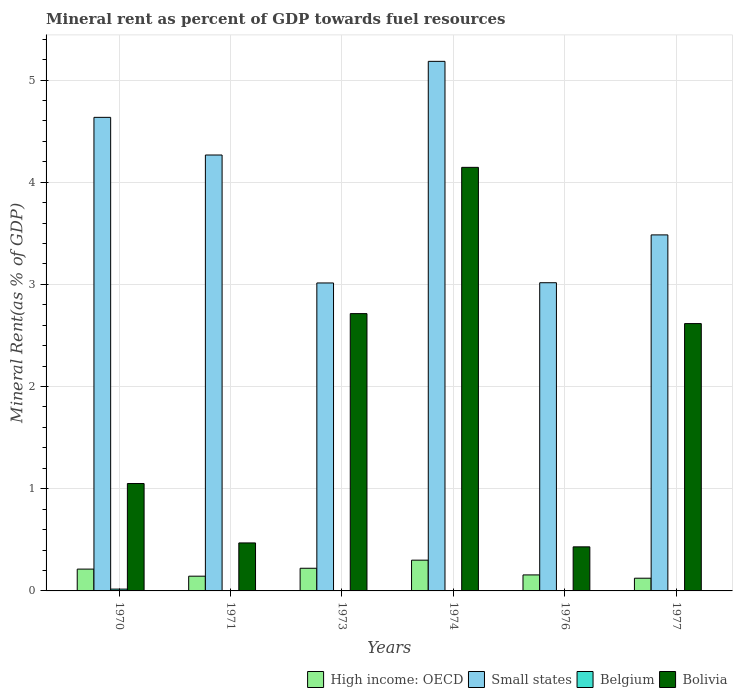How many different coloured bars are there?
Keep it short and to the point. 4. Are the number of bars per tick equal to the number of legend labels?
Provide a short and direct response. Yes. Are the number of bars on each tick of the X-axis equal?
Give a very brief answer. Yes. How many bars are there on the 5th tick from the left?
Ensure brevity in your answer.  4. What is the label of the 6th group of bars from the left?
Your answer should be very brief. 1977. In how many cases, is the number of bars for a given year not equal to the number of legend labels?
Give a very brief answer. 0. What is the mineral rent in Bolivia in 1976?
Your answer should be compact. 0.43. Across all years, what is the maximum mineral rent in Belgium?
Provide a short and direct response. 0.02. Across all years, what is the minimum mineral rent in Small states?
Provide a succinct answer. 3.01. In which year was the mineral rent in High income: OECD maximum?
Provide a short and direct response. 1974. In which year was the mineral rent in High income: OECD minimum?
Provide a succinct answer. 1977. What is the total mineral rent in Small states in the graph?
Your response must be concise. 23.6. What is the difference between the mineral rent in Bolivia in 1973 and that in 1977?
Your answer should be very brief. 0.1. What is the difference between the mineral rent in Belgium in 1973 and the mineral rent in Small states in 1976?
Provide a succinct answer. -3.02. What is the average mineral rent in Small states per year?
Ensure brevity in your answer.  3.93. In the year 1970, what is the difference between the mineral rent in Belgium and mineral rent in High income: OECD?
Ensure brevity in your answer.  -0.2. What is the ratio of the mineral rent in Bolivia in 1971 to that in 1977?
Ensure brevity in your answer.  0.18. Is the mineral rent in Belgium in 1973 less than that in 1977?
Give a very brief answer. Yes. Is the difference between the mineral rent in Belgium in 1971 and 1977 greater than the difference between the mineral rent in High income: OECD in 1971 and 1977?
Provide a succinct answer. No. What is the difference between the highest and the second highest mineral rent in Bolivia?
Give a very brief answer. 1.43. What is the difference between the highest and the lowest mineral rent in Bolivia?
Make the answer very short. 3.71. Is the sum of the mineral rent in Bolivia in 1973 and 1976 greater than the maximum mineral rent in High income: OECD across all years?
Keep it short and to the point. Yes. What does the 3rd bar from the right in 1970 represents?
Your response must be concise. Small states. Are all the bars in the graph horizontal?
Provide a short and direct response. No. How many years are there in the graph?
Keep it short and to the point. 6. Does the graph contain grids?
Offer a very short reply. Yes. What is the title of the graph?
Offer a terse response. Mineral rent as percent of GDP towards fuel resources. Does "Antigua and Barbuda" appear as one of the legend labels in the graph?
Provide a short and direct response. No. What is the label or title of the Y-axis?
Ensure brevity in your answer.  Mineral Rent(as % of GDP). What is the Mineral Rent(as % of GDP) of High income: OECD in 1970?
Provide a succinct answer. 0.21. What is the Mineral Rent(as % of GDP) in Small states in 1970?
Provide a short and direct response. 4.63. What is the Mineral Rent(as % of GDP) of Belgium in 1970?
Offer a terse response. 0.02. What is the Mineral Rent(as % of GDP) in Bolivia in 1970?
Offer a terse response. 1.05. What is the Mineral Rent(as % of GDP) in High income: OECD in 1971?
Your response must be concise. 0.14. What is the Mineral Rent(as % of GDP) of Small states in 1971?
Your answer should be compact. 4.27. What is the Mineral Rent(as % of GDP) in Belgium in 1971?
Make the answer very short. 0. What is the Mineral Rent(as % of GDP) of Bolivia in 1971?
Make the answer very short. 0.47. What is the Mineral Rent(as % of GDP) of High income: OECD in 1973?
Provide a short and direct response. 0.22. What is the Mineral Rent(as % of GDP) in Small states in 1973?
Ensure brevity in your answer.  3.01. What is the Mineral Rent(as % of GDP) in Belgium in 1973?
Provide a succinct answer. 0. What is the Mineral Rent(as % of GDP) of Bolivia in 1973?
Keep it short and to the point. 2.71. What is the Mineral Rent(as % of GDP) in High income: OECD in 1974?
Your answer should be very brief. 0.3. What is the Mineral Rent(as % of GDP) in Small states in 1974?
Give a very brief answer. 5.18. What is the Mineral Rent(as % of GDP) of Belgium in 1974?
Ensure brevity in your answer.  0. What is the Mineral Rent(as % of GDP) of Bolivia in 1974?
Offer a terse response. 4.15. What is the Mineral Rent(as % of GDP) of High income: OECD in 1976?
Offer a terse response. 0.16. What is the Mineral Rent(as % of GDP) of Small states in 1976?
Make the answer very short. 3.02. What is the Mineral Rent(as % of GDP) in Belgium in 1976?
Your answer should be compact. 0. What is the Mineral Rent(as % of GDP) of Bolivia in 1976?
Make the answer very short. 0.43. What is the Mineral Rent(as % of GDP) in High income: OECD in 1977?
Your answer should be very brief. 0.12. What is the Mineral Rent(as % of GDP) of Small states in 1977?
Keep it short and to the point. 3.48. What is the Mineral Rent(as % of GDP) in Belgium in 1977?
Provide a short and direct response. 0. What is the Mineral Rent(as % of GDP) of Bolivia in 1977?
Keep it short and to the point. 2.62. Across all years, what is the maximum Mineral Rent(as % of GDP) in High income: OECD?
Ensure brevity in your answer.  0.3. Across all years, what is the maximum Mineral Rent(as % of GDP) of Small states?
Give a very brief answer. 5.18. Across all years, what is the maximum Mineral Rent(as % of GDP) in Belgium?
Provide a short and direct response. 0.02. Across all years, what is the maximum Mineral Rent(as % of GDP) in Bolivia?
Keep it short and to the point. 4.15. Across all years, what is the minimum Mineral Rent(as % of GDP) of High income: OECD?
Your response must be concise. 0.12. Across all years, what is the minimum Mineral Rent(as % of GDP) of Small states?
Ensure brevity in your answer.  3.01. Across all years, what is the minimum Mineral Rent(as % of GDP) in Belgium?
Offer a terse response. 0. Across all years, what is the minimum Mineral Rent(as % of GDP) of Bolivia?
Provide a short and direct response. 0.43. What is the total Mineral Rent(as % of GDP) of High income: OECD in the graph?
Your answer should be compact. 1.16. What is the total Mineral Rent(as % of GDP) of Small states in the graph?
Provide a succinct answer. 23.6. What is the total Mineral Rent(as % of GDP) in Belgium in the graph?
Offer a terse response. 0.03. What is the total Mineral Rent(as % of GDP) in Bolivia in the graph?
Your response must be concise. 11.43. What is the difference between the Mineral Rent(as % of GDP) in High income: OECD in 1970 and that in 1971?
Keep it short and to the point. 0.07. What is the difference between the Mineral Rent(as % of GDP) in Small states in 1970 and that in 1971?
Offer a terse response. 0.37. What is the difference between the Mineral Rent(as % of GDP) in Belgium in 1970 and that in 1971?
Provide a succinct answer. 0.02. What is the difference between the Mineral Rent(as % of GDP) in Bolivia in 1970 and that in 1971?
Your answer should be very brief. 0.58. What is the difference between the Mineral Rent(as % of GDP) in High income: OECD in 1970 and that in 1973?
Provide a short and direct response. -0.01. What is the difference between the Mineral Rent(as % of GDP) in Small states in 1970 and that in 1973?
Your answer should be very brief. 1.62. What is the difference between the Mineral Rent(as % of GDP) in Belgium in 1970 and that in 1973?
Your answer should be compact. 0.02. What is the difference between the Mineral Rent(as % of GDP) in Bolivia in 1970 and that in 1973?
Offer a very short reply. -1.66. What is the difference between the Mineral Rent(as % of GDP) of High income: OECD in 1970 and that in 1974?
Ensure brevity in your answer.  -0.09. What is the difference between the Mineral Rent(as % of GDP) in Small states in 1970 and that in 1974?
Your answer should be very brief. -0.55. What is the difference between the Mineral Rent(as % of GDP) of Belgium in 1970 and that in 1974?
Your answer should be compact. 0.01. What is the difference between the Mineral Rent(as % of GDP) in Bolivia in 1970 and that in 1974?
Offer a very short reply. -3.09. What is the difference between the Mineral Rent(as % of GDP) in High income: OECD in 1970 and that in 1976?
Give a very brief answer. 0.06. What is the difference between the Mineral Rent(as % of GDP) in Small states in 1970 and that in 1976?
Your answer should be compact. 1.62. What is the difference between the Mineral Rent(as % of GDP) in Belgium in 1970 and that in 1976?
Your response must be concise. 0.01. What is the difference between the Mineral Rent(as % of GDP) in Bolivia in 1970 and that in 1976?
Your response must be concise. 0.62. What is the difference between the Mineral Rent(as % of GDP) of High income: OECD in 1970 and that in 1977?
Ensure brevity in your answer.  0.09. What is the difference between the Mineral Rent(as % of GDP) in Small states in 1970 and that in 1977?
Offer a very short reply. 1.15. What is the difference between the Mineral Rent(as % of GDP) of Belgium in 1970 and that in 1977?
Give a very brief answer. 0.02. What is the difference between the Mineral Rent(as % of GDP) of Bolivia in 1970 and that in 1977?
Offer a terse response. -1.57. What is the difference between the Mineral Rent(as % of GDP) of High income: OECD in 1971 and that in 1973?
Your answer should be very brief. -0.08. What is the difference between the Mineral Rent(as % of GDP) in Small states in 1971 and that in 1973?
Make the answer very short. 1.25. What is the difference between the Mineral Rent(as % of GDP) in Belgium in 1971 and that in 1973?
Your answer should be compact. 0. What is the difference between the Mineral Rent(as % of GDP) in Bolivia in 1971 and that in 1973?
Provide a short and direct response. -2.24. What is the difference between the Mineral Rent(as % of GDP) in High income: OECD in 1971 and that in 1974?
Make the answer very short. -0.16. What is the difference between the Mineral Rent(as % of GDP) of Small states in 1971 and that in 1974?
Give a very brief answer. -0.92. What is the difference between the Mineral Rent(as % of GDP) of Belgium in 1971 and that in 1974?
Give a very brief answer. -0. What is the difference between the Mineral Rent(as % of GDP) in Bolivia in 1971 and that in 1974?
Provide a succinct answer. -3.68. What is the difference between the Mineral Rent(as % of GDP) in High income: OECD in 1971 and that in 1976?
Your answer should be compact. -0.01. What is the difference between the Mineral Rent(as % of GDP) of Small states in 1971 and that in 1976?
Your response must be concise. 1.25. What is the difference between the Mineral Rent(as % of GDP) of Belgium in 1971 and that in 1976?
Give a very brief answer. -0. What is the difference between the Mineral Rent(as % of GDP) of Bolivia in 1971 and that in 1976?
Your answer should be compact. 0.04. What is the difference between the Mineral Rent(as % of GDP) of High income: OECD in 1971 and that in 1977?
Make the answer very short. 0.02. What is the difference between the Mineral Rent(as % of GDP) in Small states in 1971 and that in 1977?
Offer a terse response. 0.78. What is the difference between the Mineral Rent(as % of GDP) in Belgium in 1971 and that in 1977?
Provide a short and direct response. -0. What is the difference between the Mineral Rent(as % of GDP) in Bolivia in 1971 and that in 1977?
Ensure brevity in your answer.  -2.15. What is the difference between the Mineral Rent(as % of GDP) of High income: OECD in 1973 and that in 1974?
Ensure brevity in your answer.  -0.08. What is the difference between the Mineral Rent(as % of GDP) of Small states in 1973 and that in 1974?
Your response must be concise. -2.17. What is the difference between the Mineral Rent(as % of GDP) of Belgium in 1973 and that in 1974?
Ensure brevity in your answer.  -0. What is the difference between the Mineral Rent(as % of GDP) in Bolivia in 1973 and that in 1974?
Give a very brief answer. -1.43. What is the difference between the Mineral Rent(as % of GDP) in High income: OECD in 1973 and that in 1976?
Your response must be concise. 0.07. What is the difference between the Mineral Rent(as % of GDP) in Small states in 1973 and that in 1976?
Your response must be concise. -0. What is the difference between the Mineral Rent(as % of GDP) of Belgium in 1973 and that in 1976?
Keep it short and to the point. -0. What is the difference between the Mineral Rent(as % of GDP) of Bolivia in 1973 and that in 1976?
Your answer should be compact. 2.28. What is the difference between the Mineral Rent(as % of GDP) of High income: OECD in 1973 and that in 1977?
Your answer should be compact. 0.1. What is the difference between the Mineral Rent(as % of GDP) of Small states in 1973 and that in 1977?
Your response must be concise. -0.47. What is the difference between the Mineral Rent(as % of GDP) of Belgium in 1973 and that in 1977?
Ensure brevity in your answer.  -0. What is the difference between the Mineral Rent(as % of GDP) in Bolivia in 1973 and that in 1977?
Your answer should be compact. 0.1. What is the difference between the Mineral Rent(as % of GDP) of High income: OECD in 1974 and that in 1976?
Give a very brief answer. 0.14. What is the difference between the Mineral Rent(as % of GDP) in Small states in 1974 and that in 1976?
Give a very brief answer. 2.17. What is the difference between the Mineral Rent(as % of GDP) of Belgium in 1974 and that in 1976?
Provide a succinct answer. -0. What is the difference between the Mineral Rent(as % of GDP) in Bolivia in 1974 and that in 1976?
Ensure brevity in your answer.  3.71. What is the difference between the Mineral Rent(as % of GDP) in High income: OECD in 1974 and that in 1977?
Offer a terse response. 0.18. What is the difference between the Mineral Rent(as % of GDP) in Small states in 1974 and that in 1977?
Offer a very short reply. 1.7. What is the difference between the Mineral Rent(as % of GDP) of Belgium in 1974 and that in 1977?
Your response must be concise. 0. What is the difference between the Mineral Rent(as % of GDP) in Bolivia in 1974 and that in 1977?
Keep it short and to the point. 1.53. What is the difference between the Mineral Rent(as % of GDP) in High income: OECD in 1976 and that in 1977?
Offer a terse response. 0.03. What is the difference between the Mineral Rent(as % of GDP) in Small states in 1976 and that in 1977?
Ensure brevity in your answer.  -0.47. What is the difference between the Mineral Rent(as % of GDP) of Belgium in 1976 and that in 1977?
Make the answer very short. 0. What is the difference between the Mineral Rent(as % of GDP) of Bolivia in 1976 and that in 1977?
Make the answer very short. -2.19. What is the difference between the Mineral Rent(as % of GDP) in High income: OECD in 1970 and the Mineral Rent(as % of GDP) in Small states in 1971?
Your answer should be compact. -4.05. What is the difference between the Mineral Rent(as % of GDP) in High income: OECD in 1970 and the Mineral Rent(as % of GDP) in Belgium in 1971?
Your answer should be very brief. 0.21. What is the difference between the Mineral Rent(as % of GDP) of High income: OECD in 1970 and the Mineral Rent(as % of GDP) of Bolivia in 1971?
Make the answer very short. -0.26. What is the difference between the Mineral Rent(as % of GDP) of Small states in 1970 and the Mineral Rent(as % of GDP) of Belgium in 1971?
Provide a succinct answer. 4.63. What is the difference between the Mineral Rent(as % of GDP) of Small states in 1970 and the Mineral Rent(as % of GDP) of Bolivia in 1971?
Your answer should be compact. 4.16. What is the difference between the Mineral Rent(as % of GDP) in Belgium in 1970 and the Mineral Rent(as % of GDP) in Bolivia in 1971?
Your answer should be compact. -0.45. What is the difference between the Mineral Rent(as % of GDP) of High income: OECD in 1970 and the Mineral Rent(as % of GDP) of Small states in 1973?
Offer a terse response. -2.8. What is the difference between the Mineral Rent(as % of GDP) of High income: OECD in 1970 and the Mineral Rent(as % of GDP) of Belgium in 1973?
Your answer should be very brief. 0.21. What is the difference between the Mineral Rent(as % of GDP) of High income: OECD in 1970 and the Mineral Rent(as % of GDP) of Bolivia in 1973?
Your answer should be compact. -2.5. What is the difference between the Mineral Rent(as % of GDP) in Small states in 1970 and the Mineral Rent(as % of GDP) in Belgium in 1973?
Ensure brevity in your answer.  4.63. What is the difference between the Mineral Rent(as % of GDP) in Small states in 1970 and the Mineral Rent(as % of GDP) in Bolivia in 1973?
Offer a terse response. 1.92. What is the difference between the Mineral Rent(as % of GDP) in Belgium in 1970 and the Mineral Rent(as % of GDP) in Bolivia in 1973?
Give a very brief answer. -2.7. What is the difference between the Mineral Rent(as % of GDP) of High income: OECD in 1970 and the Mineral Rent(as % of GDP) of Small states in 1974?
Keep it short and to the point. -4.97. What is the difference between the Mineral Rent(as % of GDP) in High income: OECD in 1970 and the Mineral Rent(as % of GDP) in Belgium in 1974?
Ensure brevity in your answer.  0.21. What is the difference between the Mineral Rent(as % of GDP) in High income: OECD in 1970 and the Mineral Rent(as % of GDP) in Bolivia in 1974?
Give a very brief answer. -3.93. What is the difference between the Mineral Rent(as % of GDP) of Small states in 1970 and the Mineral Rent(as % of GDP) of Belgium in 1974?
Ensure brevity in your answer.  4.63. What is the difference between the Mineral Rent(as % of GDP) of Small states in 1970 and the Mineral Rent(as % of GDP) of Bolivia in 1974?
Your response must be concise. 0.49. What is the difference between the Mineral Rent(as % of GDP) in Belgium in 1970 and the Mineral Rent(as % of GDP) in Bolivia in 1974?
Offer a terse response. -4.13. What is the difference between the Mineral Rent(as % of GDP) in High income: OECD in 1970 and the Mineral Rent(as % of GDP) in Small states in 1976?
Keep it short and to the point. -2.8. What is the difference between the Mineral Rent(as % of GDP) in High income: OECD in 1970 and the Mineral Rent(as % of GDP) in Belgium in 1976?
Ensure brevity in your answer.  0.21. What is the difference between the Mineral Rent(as % of GDP) in High income: OECD in 1970 and the Mineral Rent(as % of GDP) in Bolivia in 1976?
Your answer should be compact. -0.22. What is the difference between the Mineral Rent(as % of GDP) in Small states in 1970 and the Mineral Rent(as % of GDP) in Belgium in 1976?
Your answer should be very brief. 4.63. What is the difference between the Mineral Rent(as % of GDP) of Small states in 1970 and the Mineral Rent(as % of GDP) of Bolivia in 1976?
Make the answer very short. 4.2. What is the difference between the Mineral Rent(as % of GDP) of Belgium in 1970 and the Mineral Rent(as % of GDP) of Bolivia in 1976?
Your response must be concise. -0.41. What is the difference between the Mineral Rent(as % of GDP) of High income: OECD in 1970 and the Mineral Rent(as % of GDP) of Small states in 1977?
Provide a short and direct response. -3.27. What is the difference between the Mineral Rent(as % of GDP) in High income: OECD in 1970 and the Mineral Rent(as % of GDP) in Belgium in 1977?
Your response must be concise. 0.21. What is the difference between the Mineral Rent(as % of GDP) of High income: OECD in 1970 and the Mineral Rent(as % of GDP) of Bolivia in 1977?
Your answer should be very brief. -2.4. What is the difference between the Mineral Rent(as % of GDP) in Small states in 1970 and the Mineral Rent(as % of GDP) in Belgium in 1977?
Make the answer very short. 4.63. What is the difference between the Mineral Rent(as % of GDP) in Small states in 1970 and the Mineral Rent(as % of GDP) in Bolivia in 1977?
Provide a short and direct response. 2.02. What is the difference between the Mineral Rent(as % of GDP) in Belgium in 1970 and the Mineral Rent(as % of GDP) in Bolivia in 1977?
Give a very brief answer. -2.6. What is the difference between the Mineral Rent(as % of GDP) in High income: OECD in 1971 and the Mineral Rent(as % of GDP) in Small states in 1973?
Ensure brevity in your answer.  -2.87. What is the difference between the Mineral Rent(as % of GDP) of High income: OECD in 1971 and the Mineral Rent(as % of GDP) of Belgium in 1973?
Provide a short and direct response. 0.14. What is the difference between the Mineral Rent(as % of GDP) in High income: OECD in 1971 and the Mineral Rent(as % of GDP) in Bolivia in 1973?
Your response must be concise. -2.57. What is the difference between the Mineral Rent(as % of GDP) in Small states in 1971 and the Mineral Rent(as % of GDP) in Belgium in 1973?
Ensure brevity in your answer.  4.27. What is the difference between the Mineral Rent(as % of GDP) of Small states in 1971 and the Mineral Rent(as % of GDP) of Bolivia in 1973?
Give a very brief answer. 1.55. What is the difference between the Mineral Rent(as % of GDP) in Belgium in 1971 and the Mineral Rent(as % of GDP) in Bolivia in 1973?
Keep it short and to the point. -2.71. What is the difference between the Mineral Rent(as % of GDP) of High income: OECD in 1971 and the Mineral Rent(as % of GDP) of Small states in 1974?
Offer a terse response. -5.04. What is the difference between the Mineral Rent(as % of GDP) in High income: OECD in 1971 and the Mineral Rent(as % of GDP) in Belgium in 1974?
Provide a succinct answer. 0.14. What is the difference between the Mineral Rent(as % of GDP) of High income: OECD in 1971 and the Mineral Rent(as % of GDP) of Bolivia in 1974?
Your response must be concise. -4. What is the difference between the Mineral Rent(as % of GDP) of Small states in 1971 and the Mineral Rent(as % of GDP) of Belgium in 1974?
Ensure brevity in your answer.  4.26. What is the difference between the Mineral Rent(as % of GDP) in Small states in 1971 and the Mineral Rent(as % of GDP) in Bolivia in 1974?
Offer a terse response. 0.12. What is the difference between the Mineral Rent(as % of GDP) of Belgium in 1971 and the Mineral Rent(as % of GDP) of Bolivia in 1974?
Give a very brief answer. -4.14. What is the difference between the Mineral Rent(as % of GDP) in High income: OECD in 1971 and the Mineral Rent(as % of GDP) in Small states in 1976?
Your response must be concise. -2.87. What is the difference between the Mineral Rent(as % of GDP) of High income: OECD in 1971 and the Mineral Rent(as % of GDP) of Belgium in 1976?
Provide a succinct answer. 0.14. What is the difference between the Mineral Rent(as % of GDP) of High income: OECD in 1971 and the Mineral Rent(as % of GDP) of Bolivia in 1976?
Provide a short and direct response. -0.29. What is the difference between the Mineral Rent(as % of GDP) of Small states in 1971 and the Mineral Rent(as % of GDP) of Belgium in 1976?
Provide a succinct answer. 4.26. What is the difference between the Mineral Rent(as % of GDP) in Small states in 1971 and the Mineral Rent(as % of GDP) in Bolivia in 1976?
Ensure brevity in your answer.  3.83. What is the difference between the Mineral Rent(as % of GDP) of Belgium in 1971 and the Mineral Rent(as % of GDP) of Bolivia in 1976?
Provide a succinct answer. -0.43. What is the difference between the Mineral Rent(as % of GDP) in High income: OECD in 1971 and the Mineral Rent(as % of GDP) in Small states in 1977?
Your answer should be compact. -3.34. What is the difference between the Mineral Rent(as % of GDP) in High income: OECD in 1971 and the Mineral Rent(as % of GDP) in Belgium in 1977?
Your answer should be compact. 0.14. What is the difference between the Mineral Rent(as % of GDP) of High income: OECD in 1971 and the Mineral Rent(as % of GDP) of Bolivia in 1977?
Your response must be concise. -2.47. What is the difference between the Mineral Rent(as % of GDP) of Small states in 1971 and the Mineral Rent(as % of GDP) of Belgium in 1977?
Provide a short and direct response. 4.26. What is the difference between the Mineral Rent(as % of GDP) in Small states in 1971 and the Mineral Rent(as % of GDP) in Bolivia in 1977?
Your answer should be very brief. 1.65. What is the difference between the Mineral Rent(as % of GDP) in Belgium in 1971 and the Mineral Rent(as % of GDP) in Bolivia in 1977?
Provide a succinct answer. -2.62. What is the difference between the Mineral Rent(as % of GDP) of High income: OECD in 1973 and the Mineral Rent(as % of GDP) of Small states in 1974?
Provide a succinct answer. -4.96. What is the difference between the Mineral Rent(as % of GDP) in High income: OECD in 1973 and the Mineral Rent(as % of GDP) in Belgium in 1974?
Make the answer very short. 0.22. What is the difference between the Mineral Rent(as % of GDP) in High income: OECD in 1973 and the Mineral Rent(as % of GDP) in Bolivia in 1974?
Provide a succinct answer. -3.92. What is the difference between the Mineral Rent(as % of GDP) of Small states in 1973 and the Mineral Rent(as % of GDP) of Belgium in 1974?
Give a very brief answer. 3.01. What is the difference between the Mineral Rent(as % of GDP) of Small states in 1973 and the Mineral Rent(as % of GDP) of Bolivia in 1974?
Make the answer very short. -1.13. What is the difference between the Mineral Rent(as % of GDP) of Belgium in 1973 and the Mineral Rent(as % of GDP) of Bolivia in 1974?
Ensure brevity in your answer.  -4.14. What is the difference between the Mineral Rent(as % of GDP) in High income: OECD in 1973 and the Mineral Rent(as % of GDP) in Small states in 1976?
Keep it short and to the point. -2.79. What is the difference between the Mineral Rent(as % of GDP) in High income: OECD in 1973 and the Mineral Rent(as % of GDP) in Belgium in 1976?
Ensure brevity in your answer.  0.22. What is the difference between the Mineral Rent(as % of GDP) in High income: OECD in 1973 and the Mineral Rent(as % of GDP) in Bolivia in 1976?
Give a very brief answer. -0.21. What is the difference between the Mineral Rent(as % of GDP) in Small states in 1973 and the Mineral Rent(as % of GDP) in Belgium in 1976?
Ensure brevity in your answer.  3.01. What is the difference between the Mineral Rent(as % of GDP) of Small states in 1973 and the Mineral Rent(as % of GDP) of Bolivia in 1976?
Your answer should be compact. 2.58. What is the difference between the Mineral Rent(as % of GDP) of Belgium in 1973 and the Mineral Rent(as % of GDP) of Bolivia in 1976?
Offer a terse response. -0.43. What is the difference between the Mineral Rent(as % of GDP) in High income: OECD in 1973 and the Mineral Rent(as % of GDP) in Small states in 1977?
Offer a very short reply. -3.26. What is the difference between the Mineral Rent(as % of GDP) in High income: OECD in 1973 and the Mineral Rent(as % of GDP) in Belgium in 1977?
Make the answer very short. 0.22. What is the difference between the Mineral Rent(as % of GDP) in High income: OECD in 1973 and the Mineral Rent(as % of GDP) in Bolivia in 1977?
Offer a very short reply. -2.39. What is the difference between the Mineral Rent(as % of GDP) in Small states in 1973 and the Mineral Rent(as % of GDP) in Belgium in 1977?
Offer a very short reply. 3.01. What is the difference between the Mineral Rent(as % of GDP) in Small states in 1973 and the Mineral Rent(as % of GDP) in Bolivia in 1977?
Your response must be concise. 0.4. What is the difference between the Mineral Rent(as % of GDP) in Belgium in 1973 and the Mineral Rent(as % of GDP) in Bolivia in 1977?
Your answer should be compact. -2.62. What is the difference between the Mineral Rent(as % of GDP) in High income: OECD in 1974 and the Mineral Rent(as % of GDP) in Small states in 1976?
Keep it short and to the point. -2.72. What is the difference between the Mineral Rent(as % of GDP) of High income: OECD in 1974 and the Mineral Rent(as % of GDP) of Belgium in 1976?
Keep it short and to the point. 0.3. What is the difference between the Mineral Rent(as % of GDP) in High income: OECD in 1974 and the Mineral Rent(as % of GDP) in Bolivia in 1976?
Provide a succinct answer. -0.13. What is the difference between the Mineral Rent(as % of GDP) in Small states in 1974 and the Mineral Rent(as % of GDP) in Belgium in 1976?
Keep it short and to the point. 5.18. What is the difference between the Mineral Rent(as % of GDP) in Small states in 1974 and the Mineral Rent(as % of GDP) in Bolivia in 1976?
Make the answer very short. 4.75. What is the difference between the Mineral Rent(as % of GDP) of Belgium in 1974 and the Mineral Rent(as % of GDP) of Bolivia in 1976?
Provide a succinct answer. -0.43. What is the difference between the Mineral Rent(as % of GDP) of High income: OECD in 1974 and the Mineral Rent(as % of GDP) of Small states in 1977?
Provide a short and direct response. -3.18. What is the difference between the Mineral Rent(as % of GDP) in High income: OECD in 1974 and the Mineral Rent(as % of GDP) in Belgium in 1977?
Give a very brief answer. 0.3. What is the difference between the Mineral Rent(as % of GDP) in High income: OECD in 1974 and the Mineral Rent(as % of GDP) in Bolivia in 1977?
Provide a succinct answer. -2.32. What is the difference between the Mineral Rent(as % of GDP) of Small states in 1974 and the Mineral Rent(as % of GDP) of Belgium in 1977?
Ensure brevity in your answer.  5.18. What is the difference between the Mineral Rent(as % of GDP) of Small states in 1974 and the Mineral Rent(as % of GDP) of Bolivia in 1977?
Provide a short and direct response. 2.57. What is the difference between the Mineral Rent(as % of GDP) in Belgium in 1974 and the Mineral Rent(as % of GDP) in Bolivia in 1977?
Give a very brief answer. -2.61. What is the difference between the Mineral Rent(as % of GDP) of High income: OECD in 1976 and the Mineral Rent(as % of GDP) of Small states in 1977?
Your answer should be compact. -3.33. What is the difference between the Mineral Rent(as % of GDP) of High income: OECD in 1976 and the Mineral Rent(as % of GDP) of Belgium in 1977?
Your response must be concise. 0.16. What is the difference between the Mineral Rent(as % of GDP) in High income: OECD in 1976 and the Mineral Rent(as % of GDP) in Bolivia in 1977?
Provide a short and direct response. -2.46. What is the difference between the Mineral Rent(as % of GDP) in Small states in 1976 and the Mineral Rent(as % of GDP) in Belgium in 1977?
Provide a succinct answer. 3.01. What is the difference between the Mineral Rent(as % of GDP) of Small states in 1976 and the Mineral Rent(as % of GDP) of Bolivia in 1977?
Keep it short and to the point. 0.4. What is the difference between the Mineral Rent(as % of GDP) in Belgium in 1976 and the Mineral Rent(as % of GDP) in Bolivia in 1977?
Offer a very short reply. -2.61. What is the average Mineral Rent(as % of GDP) in High income: OECD per year?
Your response must be concise. 0.19. What is the average Mineral Rent(as % of GDP) in Small states per year?
Offer a very short reply. 3.93. What is the average Mineral Rent(as % of GDP) in Belgium per year?
Provide a short and direct response. 0. What is the average Mineral Rent(as % of GDP) in Bolivia per year?
Your response must be concise. 1.9. In the year 1970, what is the difference between the Mineral Rent(as % of GDP) of High income: OECD and Mineral Rent(as % of GDP) of Small states?
Provide a short and direct response. -4.42. In the year 1970, what is the difference between the Mineral Rent(as % of GDP) of High income: OECD and Mineral Rent(as % of GDP) of Belgium?
Offer a terse response. 0.2. In the year 1970, what is the difference between the Mineral Rent(as % of GDP) in High income: OECD and Mineral Rent(as % of GDP) in Bolivia?
Your answer should be compact. -0.84. In the year 1970, what is the difference between the Mineral Rent(as % of GDP) of Small states and Mineral Rent(as % of GDP) of Belgium?
Provide a short and direct response. 4.62. In the year 1970, what is the difference between the Mineral Rent(as % of GDP) of Small states and Mineral Rent(as % of GDP) of Bolivia?
Offer a very short reply. 3.58. In the year 1970, what is the difference between the Mineral Rent(as % of GDP) of Belgium and Mineral Rent(as % of GDP) of Bolivia?
Your answer should be compact. -1.03. In the year 1971, what is the difference between the Mineral Rent(as % of GDP) of High income: OECD and Mineral Rent(as % of GDP) of Small states?
Give a very brief answer. -4.12. In the year 1971, what is the difference between the Mineral Rent(as % of GDP) in High income: OECD and Mineral Rent(as % of GDP) in Belgium?
Ensure brevity in your answer.  0.14. In the year 1971, what is the difference between the Mineral Rent(as % of GDP) in High income: OECD and Mineral Rent(as % of GDP) in Bolivia?
Your answer should be compact. -0.33. In the year 1971, what is the difference between the Mineral Rent(as % of GDP) of Small states and Mineral Rent(as % of GDP) of Belgium?
Offer a terse response. 4.27. In the year 1971, what is the difference between the Mineral Rent(as % of GDP) of Small states and Mineral Rent(as % of GDP) of Bolivia?
Your response must be concise. 3.8. In the year 1971, what is the difference between the Mineral Rent(as % of GDP) of Belgium and Mineral Rent(as % of GDP) of Bolivia?
Ensure brevity in your answer.  -0.47. In the year 1973, what is the difference between the Mineral Rent(as % of GDP) in High income: OECD and Mineral Rent(as % of GDP) in Small states?
Ensure brevity in your answer.  -2.79. In the year 1973, what is the difference between the Mineral Rent(as % of GDP) in High income: OECD and Mineral Rent(as % of GDP) in Belgium?
Provide a succinct answer. 0.22. In the year 1973, what is the difference between the Mineral Rent(as % of GDP) of High income: OECD and Mineral Rent(as % of GDP) of Bolivia?
Your answer should be very brief. -2.49. In the year 1973, what is the difference between the Mineral Rent(as % of GDP) in Small states and Mineral Rent(as % of GDP) in Belgium?
Give a very brief answer. 3.01. In the year 1973, what is the difference between the Mineral Rent(as % of GDP) in Small states and Mineral Rent(as % of GDP) in Bolivia?
Ensure brevity in your answer.  0.3. In the year 1973, what is the difference between the Mineral Rent(as % of GDP) of Belgium and Mineral Rent(as % of GDP) of Bolivia?
Offer a terse response. -2.71. In the year 1974, what is the difference between the Mineral Rent(as % of GDP) in High income: OECD and Mineral Rent(as % of GDP) in Small states?
Provide a short and direct response. -4.88. In the year 1974, what is the difference between the Mineral Rent(as % of GDP) in High income: OECD and Mineral Rent(as % of GDP) in Belgium?
Provide a short and direct response. 0.3. In the year 1974, what is the difference between the Mineral Rent(as % of GDP) in High income: OECD and Mineral Rent(as % of GDP) in Bolivia?
Offer a very short reply. -3.84. In the year 1974, what is the difference between the Mineral Rent(as % of GDP) of Small states and Mineral Rent(as % of GDP) of Belgium?
Ensure brevity in your answer.  5.18. In the year 1974, what is the difference between the Mineral Rent(as % of GDP) of Small states and Mineral Rent(as % of GDP) of Bolivia?
Keep it short and to the point. 1.04. In the year 1974, what is the difference between the Mineral Rent(as % of GDP) in Belgium and Mineral Rent(as % of GDP) in Bolivia?
Your answer should be compact. -4.14. In the year 1976, what is the difference between the Mineral Rent(as % of GDP) of High income: OECD and Mineral Rent(as % of GDP) of Small states?
Provide a succinct answer. -2.86. In the year 1976, what is the difference between the Mineral Rent(as % of GDP) in High income: OECD and Mineral Rent(as % of GDP) in Belgium?
Keep it short and to the point. 0.15. In the year 1976, what is the difference between the Mineral Rent(as % of GDP) of High income: OECD and Mineral Rent(as % of GDP) of Bolivia?
Give a very brief answer. -0.27. In the year 1976, what is the difference between the Mineral Rent(as % of GDP) of Small states and Mineral Rent(as % of GDP) of Belgium?
Provide a succinct answer. 3.01. In the year 1976, what is the difference between the Mineral Rent(as % of GDP) in Small states and Mineral Rent(as % of GDP) in Bolivia?
Give a very brief answer. 2.58. In the year 1976, what is the difference between the Mineral Rent(as % of GDP) of Belgium and Mineral Rent(as % of GDP) of Bolivia?
Your answer should be very brief. -0.43. In the year 1977, what is the difference between the Mineral Rent(as % of GDP) of High income: OECD and Mineral Rent(as % of GDP) of Small states?
Give a very brief answer. -3.36. In the year 1977, what is the difference between the Mineral Rent(as % of GDP) in High income: OECD and Mineral Rent(as % of GDP) in Belgium?
Provide a succinct answer. 0.12. In the year 1977, what is the difference between the Mineral Rent(as % of GDP) in High income: OECD and Mineral Rent(as % of GDP) in Bolivia?
Your answer should be compact. -2.49. In the year 1977, what is the difference between the Mineral Rent(as % of GDP) in Small states and Mineral Rent(as % of GDP) in Belgium?
Ensure brevity in your answer.  3.48. In the year 1977, what is the difference between the Mineral Rent(as % of GDP) in Small states and Mineral Rent(as % of GDP) in Bolivia?
Your response must be concise. 0.87. In the year 1977, what is the difference between the Mineral Rent(as % of GDP) of Belgium and Mineral Rent(as % of GDP) of Bolivia?
Your answer should be very brief. -2.61. What is the ratio of the Mineral Rent(as % of GDP) of High income: OECD in 1970 to that in 1971?
Make the answer very short. 1.48. What is the ratio of the Mineral Rent(as % of GDP) in Small states in 1970 to that in 1971?
Make the answer very short. 1.09. What is the ratio of the Mineral Rent(as % of GDP) in Belgium in 1970 to that in 1971?
Your response must be concise. 36.67. What is the ratio of the Mineral Rent(as % of GDP) in Bolivia in 1970 to that in 1971?
Your answer should be very brief. 2.24. What is the ratio of the Mineral Rent(as % of GDP) of High income: OECD in 1970 to that in 1973?
Your response must be concise. 0.96. What is the ratio of the Mineral Rent(as % of GDP) in Small states in 1970 to that in 1973?
Make the answer very short. 1.54. What is the ratio of the Mineral Rent(as % of GDP) in Belgium in 1970 to that in 1973?
Offer a very short reply. 80.74. What is the ratio of the Mineral Rent(as % of GDP) of Bolivia in 1970 to that in 1973?
Offer a very short reply. 0.39. What is the ratio of the Mineral Rent(as % of GDP) of High income: OECD in 1970 to that in 1974?
Ensure brevity in your answer.  0.71. What is the ratio of the Mineral Rent(as % of GDP) in Small states in 1970 to that in 1974?
Your response must be concise. 0.89. What is the ratio of the Mineral Rent(as % of GDP) in Belgium in 1970 to that in 1974?
Offer a very short reply. 6.26. What is the ratio of the Mineral Rent(as % of GDP) of Bolivia in 1970 to that in 1974?
Keep it short and to the point. 0.25. What is the ratio of the Mineral Rent(as % of GDP) of High income: OECD in 1970 to that in 1976?
Offer a terse response. 1.36. What is the ratio of the Mineral Rent(as % of GDP) of Small states in 1970 to that in 1976?
Provide a short and direct response. 1.54. What is the ratio of the Mineral Rent(as % of GDP) in Belgium in 1970 to that in 1976?
Give a very brief answer. 5.25. What is the ratio of the Mineral Rent(as % of GDP) of Bolivia in 1970 to that in 1976?
Offer a very short reply. 2.44. What is the ratio of the Mineral Rent(as % of GDP) in High income: OECD in 1970 to that in 1977?
Make the answer very short. 1.72. What is the ratio of the Mineral Rent(as % of GDP) of Small states in 1970 to that in 1977?
Offer a very short reply. 1.33. What is the ratio of the Mineral Rent(as % of GDP) of Belgium in 1970 to that in 1977?
Keep it short and to the point. 11.43. What is the ratio of the Mineral Rent(as % of GDP) in Bolivia in 1970 to that in 1977?
Offer a terse response. 0.4. What is the ratio of the Mineral Rent(as % of GDP) of High income: OECD in 1971 to that in 1973?
Make the answer very short. 0.65. What is the ratio of the Mineral Rent(as % of GDP) in Small states in 1971 to that in 1973?
Provide a short and direct response. 1.42. What is the ratio of the Mineral Rent(as % of GDP) of Belgium in 1971 to that in 1973?
Keep it short and to the point. 2.2. What is the ratio of the Mineral Rent(as % of GDP) of Bolivia in 1971 to that in 1973?
Make the answer very short. 0.17. What is the ratio of the Mineral Rent(as % of GDP) in High income: OECD in 1971 to that in 1974?
Provide a short and direct response. 0.48. What is the ratio of the Mineral Rent(as % of GDP) of Small states in 1971 to that in 1974?
Your response must be concise. 0.82. What is the ratio of the Mineral Rent(as % of GDP) in Belgium in 1971 to that in 1974?
Give a very brief answer. 0.17. What is the ratio of the Mineral Rent(as % of GDP) in Bolivia in 1971 to that in 1974?
Ensure brevity in your answer.  0.11. What is the ratio of the Mineral Rent(as % of GDP) in High income: OECD in 1971 to that in 1976?
Provide a short and direct response. 0.92. What is the ratio of the Mineral Rent(as % of GDP) of Small states in 1971 to that in 1976?
Your answer should be compact. 1.41. What is the ratio of the Mineral Rent(as % of GDP) of Belgium in 1971 to that in 1976?
Keep it short and to the point. 0.14. What is the ratio of the Mineral Rent(as % of GDP) of Bolivia in 1971 to that in 1976?
Provide a short and direct response. 1.09. What is the ratio of the Mineral Rent(as % of GDP) of High income: OECD in 1971 to that in 1977?
Make the answer very short. 1.16. What is the ratio of the Mineral Rent(as % of GDP) of Small states in 1971 to that in 1977?
Make the answer very short. 1.22. What is the ratio of the Mineral Rent(as % of GDP) of Belgium in 1971 to that in 1977?
Keep it short and to the point. 0.31. What is the ratio of the Mineral Rent(as % of GDP) of Bolivia in 1971 to that in 1977?
Provide a succinct answer. 0.18. What is the ratio of the Mineral Rent(as % of GDP) in High income: OECD in 1973 to that in 1974?
Provide a short and direct response. 0.74. What is the ratio of the Mineral Rent(as % of GDP) in Small states in 1973 to that in 1974?
Give a very brief answer. 0.58. What is the ratio of the Mineral Rent(as % of GDP) in Belgium in 1973 to that in 1974?
Your answer should be compact. 0.08. What is the ratio of the Mineral Rent(as % of GDP) of Bolivia in 1973 to that in 1974?
Your answer should be very brief. 0.65. What is the ratio of the Mineral Rent(as % of GDP) of High income: OECD in 1973 to that in 1976?
Make the answer very short. 1.42. What is the ratio of the Mineral Rent(as % of GDP) of Small states in 1973 to that in 1976?
Your response must be concise. 1. What is the ratio of the Mineral Rent(as % of GDP) of Belgium in 1973 to that in 1976?
Keep it short and to the point. 0.07. What is the ratio of the Mineral Rent(as % of GDP) in Bolivia in 1973 to that in 1976?
Offer a very short reply. 6.29. What is the ratio of the Mineral Rent(as % of GDP) of High income: OECD in 1973 to that in 1977?
Your response must be concise. 1.78. What is the ratio of the Mineral Rent(as % of GDP) of Small states in 1973 to that in 1977?
Keep it short and to the point. 0.86. What is the ratio of the Mineral Rent(as % of GDP) of Belgium in 1973 to that in 1977?
Keep it short and to the point. 0.14. What is the ratio of the Mineral Rent(as % of GDP) in Bolivia in 1973 to that in 1977?
Offer a very short reply. 1.04. What is the ratio of the Mineral Rent(as % of GDP) in High income: OECD in 1974 to that in 1976?
Offer a terse response. 1.92. What is the ratio of the Mineral Rent(as % of GDP) in Small states in 1974 to that in 1976?
Provide a succinct answer. 1.72. What is the ratio of the Mineral Rent(as % of GDP) in Belgium in 1974 to that in 1976?
Your answer should be very brief. 0.84. What is the ratio of the Mineral Rent(as % of GDP) in Bolivia in 1974 to that in 1976?
Offer a terse response. 9.61. What is the ratio of the Mineral Rent(as % of GDP) of High income: OECD in 1974 to that in 1977?
Offer a very short reply. 2.42. What is the ratio of the Mineral Rent(as % of GDP) of Small states in 1974 to that in 1977?
Your answer should be very brief. 1.49. What is the ratio of the Mineral Rent(as % of GDP) of Belgium in 1974 to that in 1977?
Keep it short and to the point. 1.83. What is the ratio of the Mineral Rent(as % of GDP) in Bolivia in 1974 to that in 1977?
Your answer should be very brief. 1.58. What is the ratio of the Mineral Rent(as % of GDP) in High income: OECD in 1976 to that in 1977?
Provide a succinct answer. 1.26. What is the ratio of the Mineral Rent(as % of GDP) of Small states in 1976 to that in 1977?
Give a very brief answer. 0.87. What is the ratio of the Mineral Rent(as % of GDP) of Belgium in 1976 to that in 1977?
Offer a very short reply. 2.18. What is the ratio of the Mineral Rent(as % of GDP) of Bolivia in 1976 to that in 1977?
Provide a succinct answer. 0.16. What is the difference between the highest and the second highest Mineral Rent(as % of GDP) of High income: OECD?
Offer a very short reply. 0.08. What is the difference between the highest and the second highest Mineral Rent(as % of GDP) of Small states?
Ensure brevity in your answer.  0.55. What is the difference between the highest and the second highest Mineral Rent(as % of GDP) in Belgium?
Your answer should be very brief. 0.01. What is the difference between the highest and the second highest Mineral Rent(as % of GDP) of Bolivia?
Ensure brevity in your answer.  1.43. What is the difference between the highest and the lowest Mineral Rent(as % of GDP) of High income: OECD?
Keep it short and to the point. 0.18. What is the difference between the highest and the lowest Mineral Rent(as % of GDP) in Small states?
Provide a succinct answer. 2.17. What is the difference between the highest and the lowest Mineral Rent(as % of GDP) of Belgium?
Ensure brevity in your answer.  0.02. What is the difference between the highest and the lowest Mineral Rent(as % of GDP) in Bolivia?
Give a very brief answer. 3.71. 